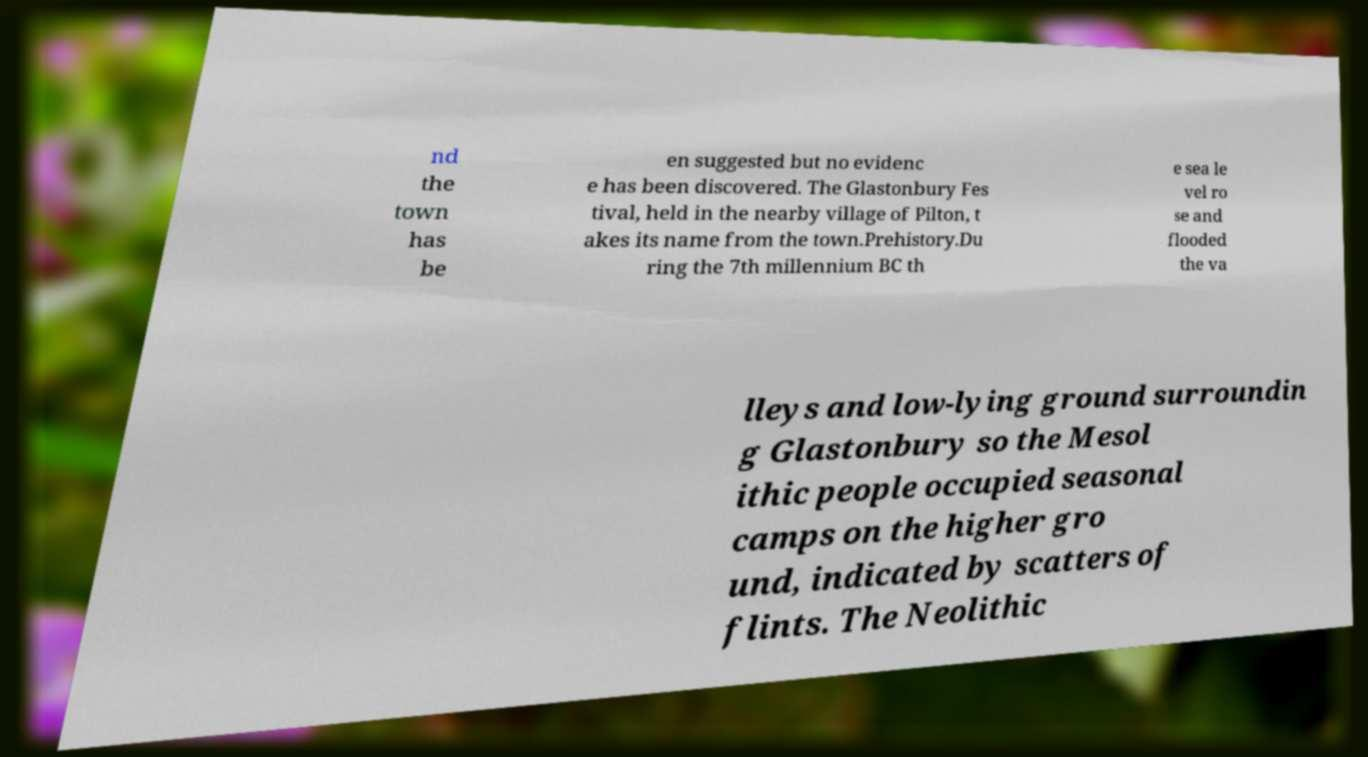Please identify and transcribe the text found in this image. nd the town has be en suggested but no evidenc e has been discovered. The Glastonbury Fes tival, held in the nearby village of Pilton, t akes its name from the town.Prehistory.Du ring the 7th millennium BC th e sea le vel ro se and flooded the va lleys and low-lying ground surroundin g Glastonbury so the Mesol ithic people occupied seasonal camps on the higher gro und, indicated by scatters of flints. The Neolithic 